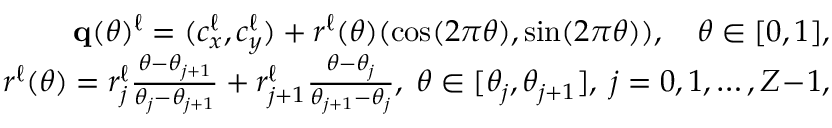Convert formula to latex. <formula><loc_0><loc_0><loc_500><loc_500>\begin{array} { r } { \mathbf q ( \theta ) ^ { \ell } = ( c _ { x } ^ { \ell } , c _ { y } ^ { \ell } ) + r ^ { \ell } ( \theta ) ( \cos ( 2 \pi \theta ) , \sin ( 2 \pi \theta ) ) , \quad \theta \in [ 0 , 1 ] , } \\ { r ^ { \ell } ( \theta ) = r _ { j } ^ { \ell } { \frac { \theta - \theta _ { j + 1 } } { \theta _ { j } - \theta _ { j + 1 } } } + r _ { j + 1 } ^ { \ell } { \frac { \theta - \theta _ { j } } { \theta _ { j + 1 } - \theta _ { j } } } , \, \theta \in [ \theta _ { j } , \theta _ { j + 1 } ] , \, j = 0 , 1 , \dots , Z \, - \, 1 , } \end{array}</formula> 